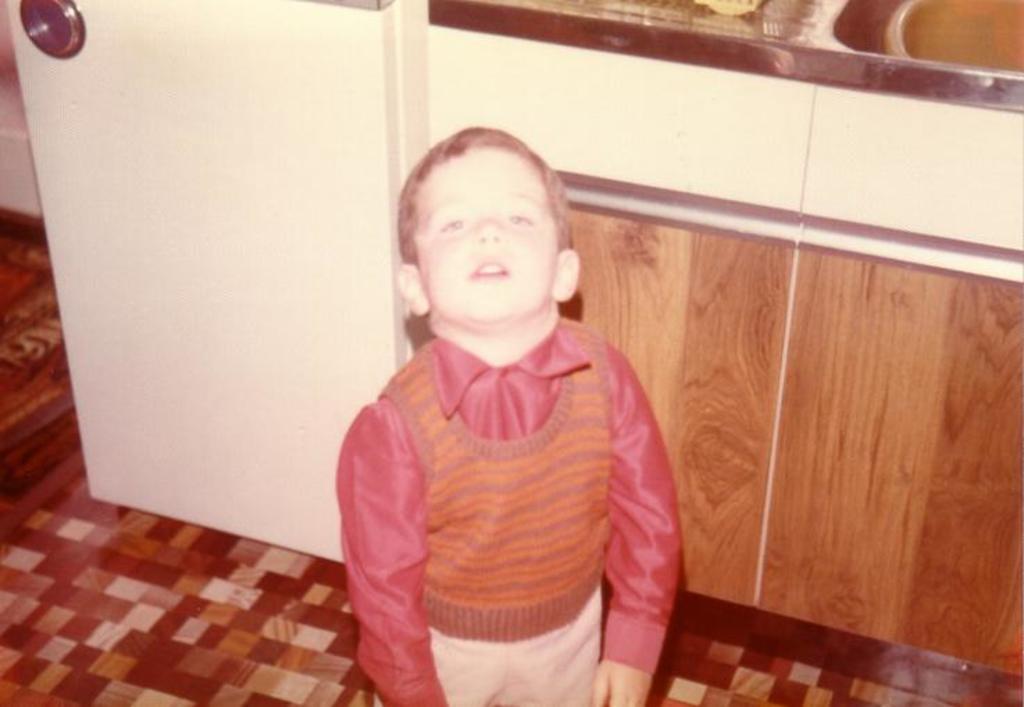Please provide a concise description of this image. In this image there is a kid standing on a floor, in the background there is a kitchen floor. 